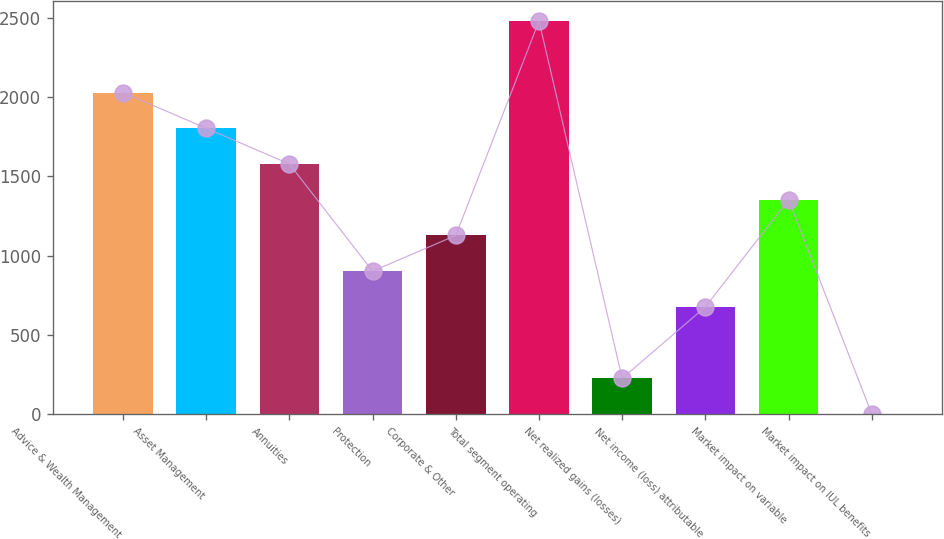Convert chart to OTSL. <chart><loc_0><loc_0><loc_500><loc_500><bar_chart><fcel>Advice & Wealth Management<fcel>Asset Management<fcel>Annuities<fcel>Protection<fcel>Corporate & Other<fcel>Total segment operating<fcel>Net realized gains (losses)<fcel>Net income (loss) attributable<fcel>Market impact on variable<fcel>Market impact on IUL benefits<nl><fcel>2028.7<fcel>1803.4<fcel>1578.1<fcel>902.2<fcel>1127.5<fcel>2479.3<fcel>226.3<fcel>676.9<fcel>1352.8<fcel>1<nl></chart> 